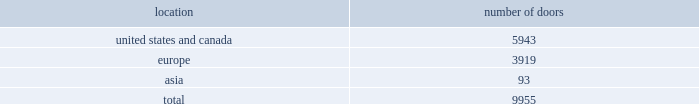Table of contents global brand concepts american living launched exclusively at jcpenney in february 2008 , american living offers classic american style with a fresh , modern spirit and authentic sensibility .
From everyday essentials to special occasion looks for the entire family to finely crafted bedding and home furnishings , american living promises stylish clothing and home products that are exceptionally made and offered at an incredible value .
American living is available exclusively at jcpenney and jcp.com .
Chaps translates the classic heritage and timeless aesthetic of ralph lauren into an accessible line for men , women , children and the home .
From casual basics designed for versatility and ease of wear to smart , finely tailored silhouettes perfect for business and more formal occasions , chaps creates interchangeable classics that are both enduring and affordable .
The chaps men 2019s collection is available at select department and specialty stores .
The chaps collections for women , children and the home are available exclusively at kohl 2019s and kohls.com .
Our wholesale segment our wholesale segment sells our products to leading upscale and certain mid-tier department stores , specialty stores and golf and pro shops , both domestically and internationally .
We have continued to focus on elevating our brand by improving in-store product assortment and presentation , and improving full-price sell-throughs to consumers .
As of the end of fiscal 2011 , our ralph lauren- branded products were sold through approximately 10000 doors worldwide and during fiscal 2011 , we invested approximately $ 35 million in related shop-within-shops primarily in domestic and international department and specialty stores .
Department stores are our major wholesale customers in north america .
In europe , our wholesale sales are a varying mix of sales to both department stores and specialty shops , depending on the country .
Our collection brands 2014 women 2019s ralph lauren collection and black label and men 2019s purple label and black label 2014 are distributed through a limited number of premier fashion retailers .
In addition , we sell excess and out-of-season products through secondary distribution channels , including our retail factory stores .
In japan , our wholesale products are distributed primarily through shop-within-shops at premiere and top-tier department stores , and the mix of business is weighted to women 2019s blue label .
In asia ( excluding japan and south korea ) , our wholesale products are sold at mid and top- tier department stores , and the mix of business is primarily weighted to men 2019s and women 2019s blue label .
In asia and on a worldwide basis , products distributed through concessions-based sales arrangements are reported within our retail segment ( see 201cour retail segment 201d for further discussion ) .
Worldwide distribution channels the table presents the number of doors by geographic location , in which ralph lauren-branded products distributed by our wholesale segment were sold to consumers in our primary channels of distribution as of april 2 , 2011 : number of location doors .
In addition , american living and chaps-branded products distributed by our wholesale segment were sold domestically through approximately 1700 doors as of april 2 , 2011. .
What percentage of total doors is the europe geography? 
Computations: (3919 / 9955)
Answer: 0.39367. 